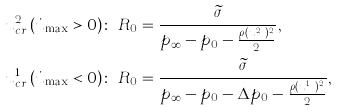Convert formula to latex. <formula><loc_0><loc_0><loc_500><loc_500>u _ { c r } ^ { 2 } \left ( \dot { u } _ { \max } > 0 \right ) & \colon \ R _ { 0 } = \frac { \widetilde { \sigma } } { p _ { \infty } - p _ { 0 } - \frac { \rho ( u _ { c r } ^ { 2 } ) ^ { 2 } } { 2 } } , \\ u _ { c r } ^ { 1 } \left ( \dot { u } _ { \max } < 0 \right ) & \colon \ R _ { 0 } = \frac { \widetilde { \sigma } } { p _ { \infty } - p _ { 0 } - \Delta p _ { 0 } - \frac { \rho ( u _ { c r } ^ { 1 } ) ^ { 2 } } { 2 } } ,</formula> 